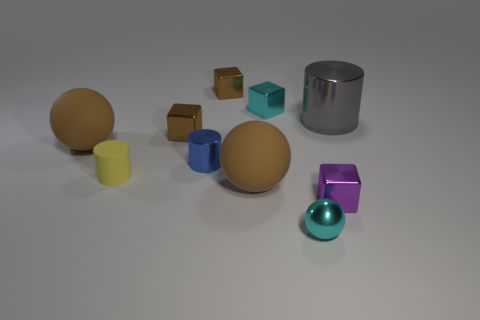What number of tiny cubes are both right of the cyan ball and on the left side of the small cyan cube?
Provide a succinct answer. 0. What number of other objects are there of the same size as the blue metal object?
Provide a succinct answer. 6. Is the number of tiny rubber cylinders that are to the right of the blue cylinder the same as the number of blue blocks?
Give a very brief answer. Yes. There is a object to the left of the small yellow rubber object; does it have the same color as the large rubber sphere in front of the small metallic cylinder?
Keep it short and to the point. Yes. What is the material of the thing that is behind the yellow cylinder and to the right of the tiny shiny sphere?
Your answer should be compact. Metal. What is the color of the tiny rubber cylinder?
Your response must be concise. Yellow. What number of other things are the same shape as the big shiny object?
Offer a terse response. 2. Are there an equal number of tiny shiny things on the right side of the cyan sphere and big gray metallic things that are in front of the large gray metal cylinder?
Offer a terse response. No. What is the cyan sphere made of?
Your answer should be compact. Metal. What is the brown sphere that is in front of the tiny blue metal cylinder made of?
Make the answer very short. Rubber. 